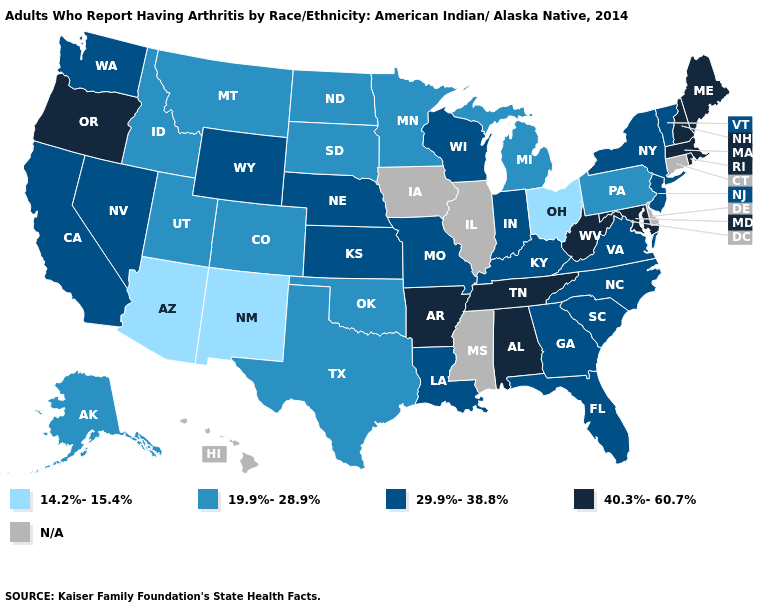What is the value of Ohio?
Concise answer only. 14.2%-15.4%. Among the states that border Kansas , does Nebraska have the highest value?
Quick response, please. Yes. What is the value of Georgia?
Quick response, please. 29.9%-38.8%. Among the states that border Texas , which have the lowest value?
Give a very brief answer. New Mexico. Name the states that have a value in the range N/A?
Answer briefly. Connecticut, Delaware, Hawaii, Illinois, Iowa, Mississippi. How many symbols are there in the legend?
Keep it brief. 5. Does the first symbol in the legend represent the smallest category?
Answer briefly. Yes. Name the states that have a value in the range 19.9%-28.9%?
Give a very brief answer. Alaska, Colorado, Idaho, Michigan, Minnesota, Montana, North Dakota, Oklahoma, Pennsylvania, South Dakota, Texas, Utah. Which states have the lowest value in the USA?
Write a very short answer. Arizona, New Mexico, Ohio. Name the states that have a value in the range N/A?
Keep it brief. Connecticut, Delaware, Hawaii, Illinois, Iowa, Mississippi. Name the states that have a value in the range 14.2%-15.4%?
Be succinct. Arizona, New Mexico, Ohio. Name the states that have a value in the range 14.2%-15.4%?
Short answer required. Arizona, New Mexico, Ohio. Does Alaska have the lowest value in the USA?
Concise answer only. No. What is the highest value in states that border Indiana?
Be succinct. 29.9%-38.8%. Name the states that have a value in the range 40.3%-60.7%?
Concise answer only. Alabama, Arkansas, Maine, Maryland, Massachusetts, New Hampshire, Oregon, Rhode Island, Tennessee, West Virginia. 